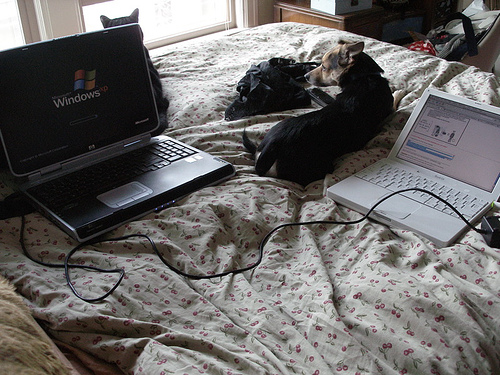Please transcribe the text in this image. Windows 